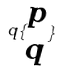Convert formula to latex. <formula><loc_0><loc_0><loc_500><loc_500>q \{ \begin{matrix} p \\ q \end{matrix} \}</formula> 